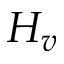Convert formula to latex. <formula><loc_0><loc_0><loc_500><loc_500>H _ { v }</formula> 